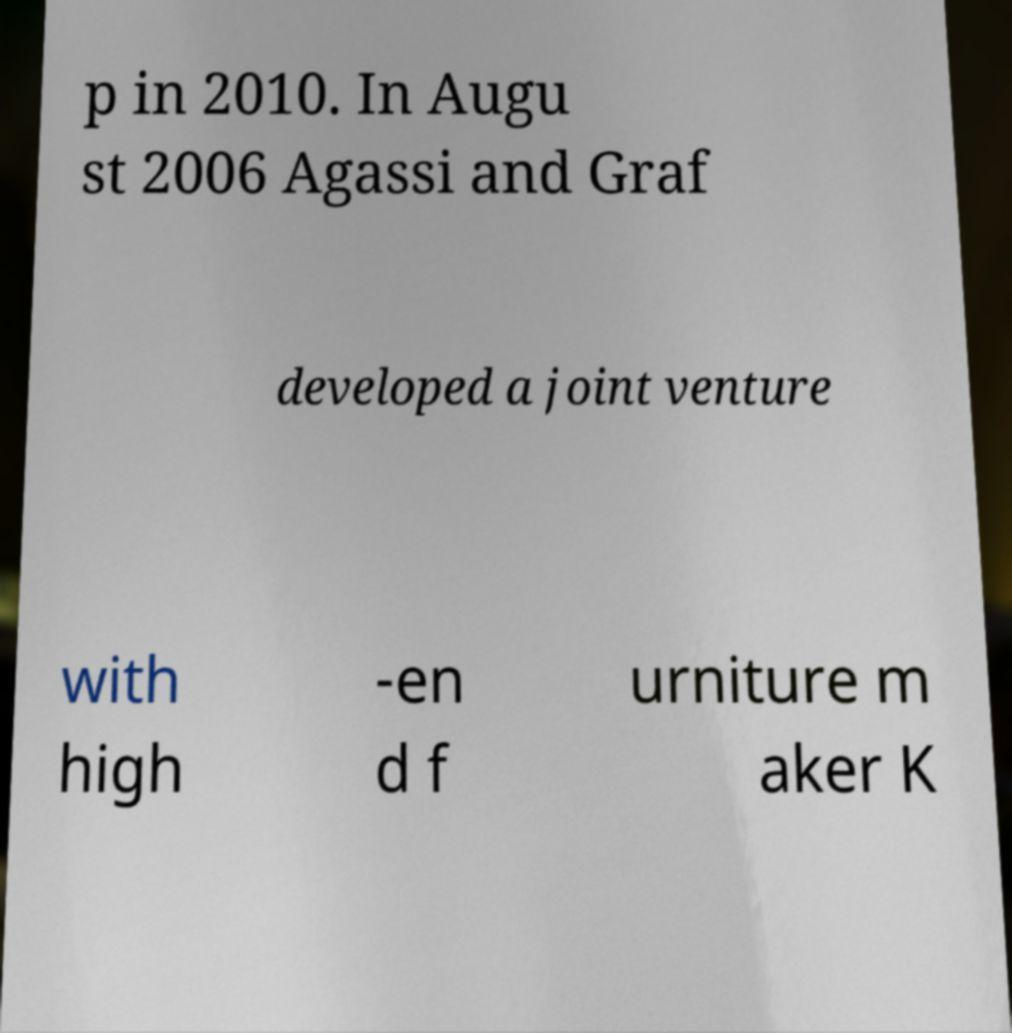Could you assist in decoding the text presented in this image and type it out clearly? p in 2010. In Augu st 2006 Agassi and Graf developed a joint venture with high -en d f urniture m aker K 